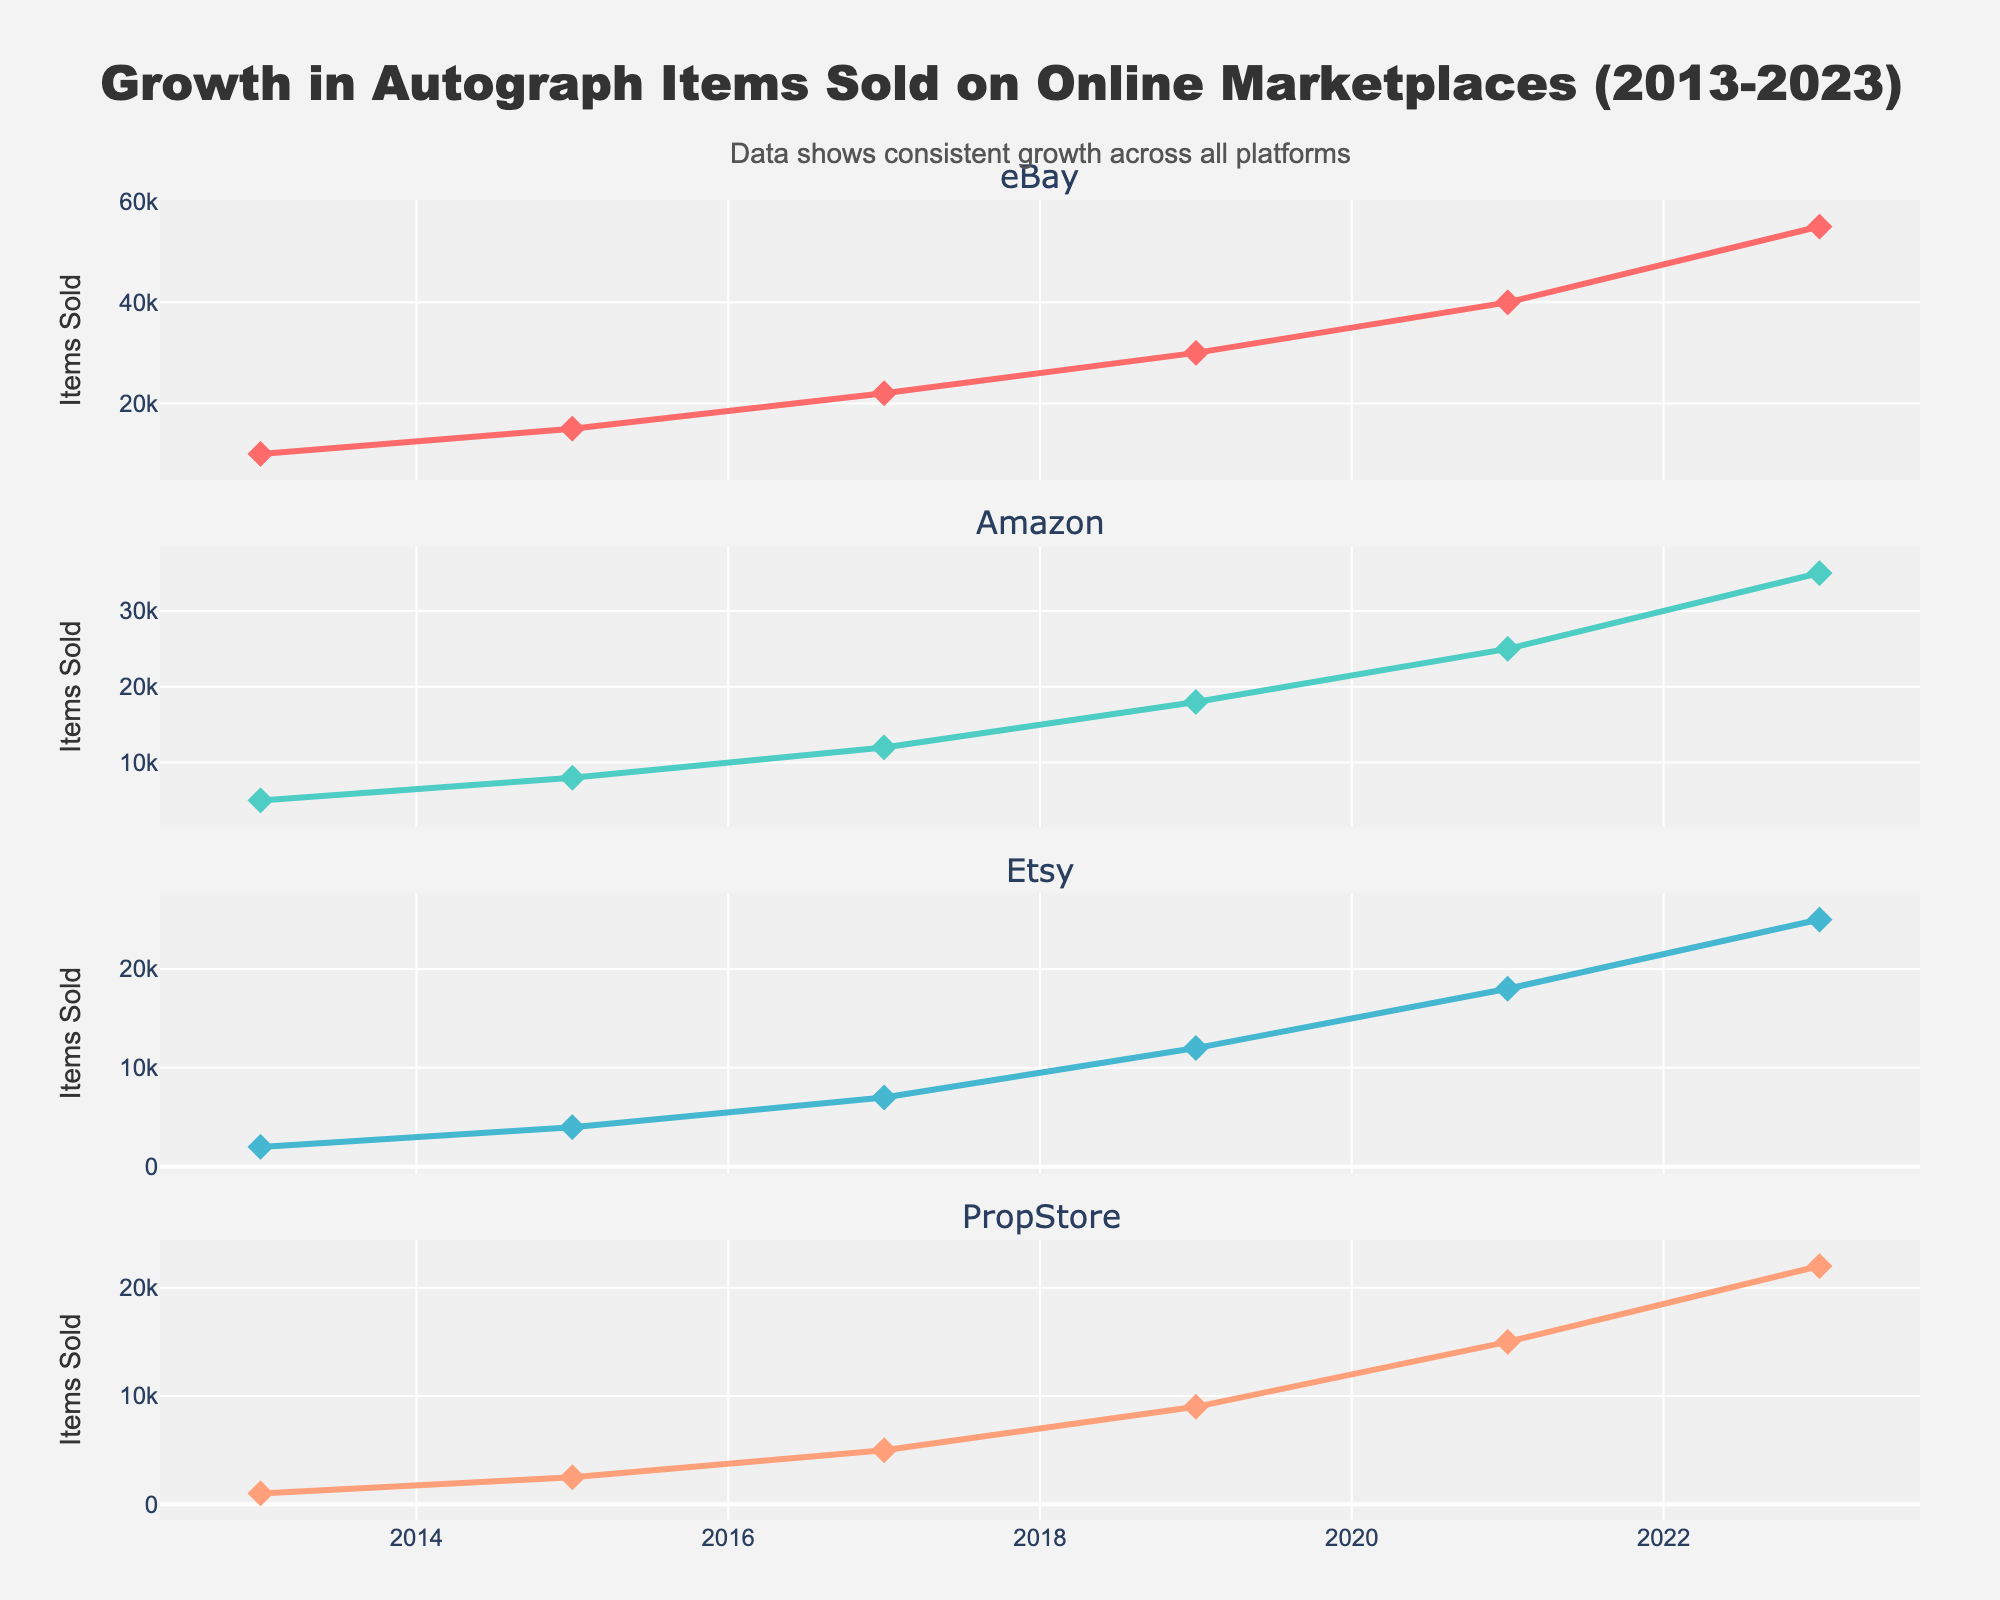What's the title of the subplot in the top-left corner? The subplot titles are given in the initial code setup. The top-left subplot has the title "Publication Timeline".
Answer: Publication Timeline How many novels did John Cheever publish? The data provides information on the type of each publication. Counting the number of "Novel" entries, we have: The Wapshot Chronicle, The Wapshot Scandal, Bullet Park, Falconer, Oh What a Paradise It Seems.
Answer: 5 What was the initial print run for the novel 'Falconer'? The data includes initial print run numbers for each title. For 'Falconer' published in 1977, the initial print run was 20,000.
Answer: 20000 Which type of publication had the highest initial print run? Examining the plot in the "Initial Print Run by Type" subplot, the bar representing "Short Story Collection" reaches the highest point, specifically for "The Stories of John Cheever".
Answer: Short Story Collection Which publisher did John Cheever have the most publications with? The subplot titled "Publishers Over Time" shows the distribution by publisher. Alfred A. Knopf appears the most frequently in this subplot.
Answer: Alfred A. Knopf What is the range of initial print runs for John Cheever's publications? The box plot in the bottom-right subplot titled "Print Run Distribution" helps identify the range. The minimum initial print run is 7,500, and the maximum is 30,000.
Answer: 7500 to 30000 How many short story collections did John Cheever publish? The data provides types and titles. Counting the entries of type "Short Story Collection", we see: Some People Places and Things That Will Not Appear in My Next Novel, The World of Apples, The Stories of John Cheever.
Answer: 3 Which year saw the highest initial print run for any publication? Looking at both the "Initial Print Run by Type" and the data, the year with the highest print run is 1991 for "The Journals of John Cheever" with 30,000 copies.
Answer: 1991 Between which years was there the longest gap in publications by John Cheever? Using the "Publication Timeline" subplot, the longest gap between publications was between 1982 ('Oh What a Paradise It Seems') and 1991 ('The Journals of John Cheever').
Answer: 1982 to 1991 What types of publications did John Cheever produce other than novels and short story collections? From the data and the plot, we can see that there is one non-fiction work "The Journals of John Cheever".
Answer: Non-fiction 